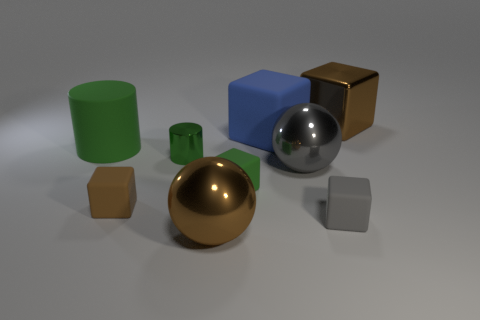How many matte objects are cylinders or big blue spheres?
Make the answer very short. 1. Are there fewer tiny green blocks that are behind the green rubber cylinder than gray metal balls?
Your response must be concise. Yes. The big brown object left of the big gray metal object that is in front of the big brown metal cube that is on the right side of the big blue rubber thing is what shape?
Offer a terse response. Sphere. Is the color of the large cylinder the same as the small metallic cylinder?
Your response must be concise. Yes. Is the number of brown shiny spheres greater than the number of large shiny spheres?
Give a very brief answer. No. How many other objects are the same material as the big cylinder?
Your answer should be compact. 4. What number of things are either metallic balls or blocks that are to the right of the tiny green cylinder?
Make the answer very short. 6. Are there fewer brown rubber things than yellow rubber things?
Provide a short and direct response. No. There is a sphere that is in front of the rubber object that is right of the big ball that is behind the small green matte thing; what color is it?
Keep it short and to the point. Brown. Does the gray cube have the same material as the large cylinder?
Offer a very short reply. Yes. 